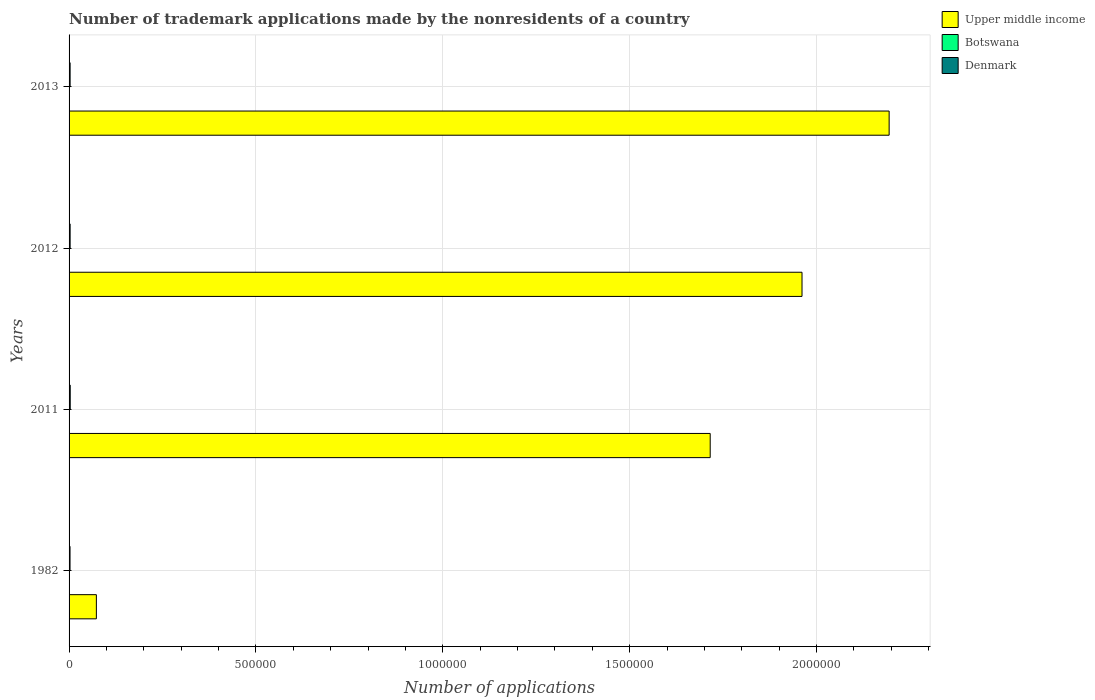How many different coloured bars are there?
Provide a short and direct response. 3. How many groups of bars are there?
Provide a short and direct response. 4. Are the number of bars per tick equal to the number of legend labels?
Your answer should be compact. Yes. How many bars are there on the 1st tick from the top?
Make the answer very short. 3. What is the number of trademark applications made by the nonresidents in Upper middle income in 1982?
Your response must be concise. 7.31e+04. Across all years, what is the maximum number of trademark applications made by the nonresidents in Botswana?
Your answer should be compact. 411. Across all years, what is the minimum number of trademark applications made by the nonresidents in Denmark?
Provide a short and direct response. 2556. In which year was the number of trademark applications made by the nonresidents in Botswana maximum?
Offer a very short reply. 2012. What is the total number of trademark applications made by the nonresidents in Upper middle income in the graph?
Ensure brevity in your answer.  5.94e+06. What is the difference between the number of trademark applications made by the nonresidents in Botswana in 2012 and that in 2013?
Provide a succinct answer. 53. What is the difference between the number of trademark applications made by the nonresidents in Denmark in 2013 and the number of trademark applications made by the nonresidents in Botswana in 1982?
Your answer should be very brief. 2789. What is the average number of trademark applications made by the nonresidents in Botswana per year?
Offer a very short reply. 275.5. In the year 1982, what is the difference between the number of trademark applications made by the nonresidents in Denmark and number of trademark applications made by the nonresidents in Upper middle income?
Offer a terse response. -7.05e+04. What is the ratio of the number of trademark applications made by the nonresidents in Upper middle income in 2011 to that in 2012?
Offer a terse response. 0.87. Is the number of trademark applications made by the nonresidents in Upper middle income in 2011 less than that in 2013?
Offer a terse response. Yes. Is the difference between the number of trademark applications made by the nonresidents in Denmark in 1982 and 2012 greater than the difference between the number of trademark applications made by the nonresidents in Upper middle income in 1982 and 2012?
Make the answer very short. Yes. What is the difference between the highest and the second highest number of trademark applications made by the nonresidents in Botswana?
Provide a succinct answer. 53. What is the difference between the highest and the lowest number of trademark applications made by the nonresidents in Upper middle income?
Ensure brevity in your answer.  2.12e+06. Is the sum of the number of trademark applications made by the nonresidents in Upper middle income in 2011 and 2012 greater than the maximum number of trademark applications made by the nonresidents in Botswana across all years?
Ensure brevity in your answer.  Yes. What does the 3rd bar from the top in 2013 represents?
Ensure brevity in your answer.  Upper middle income. What does the 2nd bar from the bottom in 2012 represents?
Make the answer very short. Botswana. How many bars are there?
Ensure brevity in your answer.  12. Are all the bars in the graph horizontal?
Your answer should be very brief. Yes. Are the values on the major ticks of X-axis written in scientific E-notation?
Ensure brevity in your answer.  No. Does the graph contain any zero values?
Keep it short and to the point. No. How many legend labels are there?
Keep it short and to the point. 3. What is the title of the graph?
Provide a short and direct response. Number of trademark applications made by the nonresidents of a country. What is the label or title of the X-axis?
Ensure brevity in your answer.  Number of applications. What is the label or title of the Y-axis?
Provide a short and direct response. Years. What is the Number of applications of Upper middle income in 1982?
Keep it short and to the point. 7.31e+04. What is the Number of applications in Botswana in 1982?
Provide a succinct answer. 4. What is the Number of applications of Denmark in 1982?
Ensure brevity in your answer.  2556. What is the Number of applications in Upper middle income in 2011?
Keep it short and to the point. 1.72e+06. What is the Number of applications in Botswana in 2011?
Give a very brief answer. 329. What is the Number of applications in Denmark in 2011?
Keep it short and to the point. 3060. What is the Number of applications in Upper middle income in 2012?
Keep it short and to the point. 1.96e+06. What is the Number of applications in Botswana in 2012?
Your answer should be very brief. 411. What is the Number of applications in Denmark in 2012?
Your answer should be compact. 2803. What is the Number of applications of Upper middle income in 2013?
Your answer should be compact. 2.19e+06. What is the Number of applications of Botswana in 2013?
Your answer should be very brief. 358. What is the Number of applications in Denmark in 2013?
Give a very brief answer. 2793. Across all years, what is the maximum Number of applications of Upper middle income?
Keep it short and to the point. 2.19e+06. Across all years, what is the maximum Number of applications in Botswana?
Your answer should be compact. 411. Across all years, what is the maximum Number of applications in Denmark?
Make the answer very short. 3060. Across all years, what is the minimum Number of applications in Upper middle income?
Provide a succinct answer. 7.31e+04. Across all years, what is the minimum Number of applications in Botswana?
Keep it short and to the point. 4. Across all years, what is the minimum Number of applications of Denmark?
Provide a short and direct response. 2556. What is the total Number of applications of Upper middle income in the graph?
Make the answer very short. 5.94e+06. What is the total Number of applications of Botswana in the graph?
Your answer should be compact. 1102. What is the total Number of applications in Denmark in the graph?
Give a very brief answer. 1.12e+04. What is the difference between the Number of applications in Upper middle income in 1982 and that in 2011?
Provide a short and direct response. -1.64e+06. What is the difference between the Number of applications of Botswana in 1982 and that in 2011?
Ensure brevity in your answer.  -325. What is the difference between the Number of applications of Denmark in 1982 and that in 2011?
Ensure brevity in your answer.  -504. What is the difference between the Number of applications of Upper middle income in 1982 and that in 2012?
Your response must be concise. -1.89e+06. What is the difference between the Number of applications of Botswana in 1982 and that in 2012?
Your response must be concise. -407. What is the difference between the Number of applications in Denmark in 1982 and that in 2012?
Make the answer very short. -247. What is the difference between the Number of applications of Upper middle income in 1982 and that in 2013?
Offer a very short reply. -2.12e+06. What is the difference between the Number of applications of Botswana in 1982 and that in 2013?
Offer a very short reply. -354. What is the difference between the Number of applications of Denmark in 1982 and that in 2013?
Provide a short and direct response. -237. What is the difference between the Number of applications of Upper middle income in 2011 and that in 2012?
Give a very brief answer. -2.46e+05. What is the difference between the Number of applications of Botswana in 2011 and that in 2012?
Make the answer very short. -82. What is the difference between the Number of applications of Denmark in 2011 and that in 2012?
Give a very brief answer. 257. What is the difference between the Number of applications of Upper middle income in 2011 and that in 2013?
Give a very brief answer. -4.79e+05. What is the difference between the Number of applications of Denmark in 2011 and that in 2013?
Your response must be concise. 267. What is the difference between the Number of applications of Upper middle income in 2012 and that in 2013?
Make the answer very short. -2.33e+05. What is the difference between the Number of applications in Denmark in 2012 and that in 2013?
Your answer should be very brief. 10. What is the difference between the Number of applications in Upper middle income in 1982 and the Number of applications in Botswana in 2011?
Keep it short and to the point. 7.27e+04. What is the difference between the Number of applications of Upper middle income in 1982 and the Number of applications of Denmark in 2011?
Make the answer very short. 7.00e+04. What is the difference between the Number of applications of Botswana in 1982 and the Number of applications of Denmark in 2011?
Your response must be concise. -3056. What is the difference between the Number of applications of Upper middle income in 1982 and the Number of applications of Botswana in 2012?
Make the answer very short. 7.27e+04. What is the difference between the Number of applications in Upper middle income in 1982 and the Number of applications in Denmark in 2012?
Give a very brief answer. 7.03e+04. What is the difference between the Number of applications of Botswana in 1982 and the Number of applications of Denmark in 2012?
Provide a short and direct response. -2799. What is the difference between the Number of applications in Upper middle income in 1982 and the Number of applications in Botswana in 2013?
Keep it short and to the point. 7.27e+04. What is the difference between the Number of applications in Upper middle income in 1982 and the Number of applications in Denmark in 2013?
Your response must be concise. 7.03e+04. What is the difference between the Number of applications of Botswana in 1982 and the Number of applications of Denmark in 2013?
Provide a short and direct response. -2789. What is the difference between the Number of applications in Upper middle income in 2011 and the Number of applications in Botswana in 2012?
Ensure brevity in your answer.  1.72e+06. What is the difference between the Number of applications in Upper middle income in 2011 and the Number of applications in Denmark in 2012?
Your response must be concise. 1.71e+06. What is the difference between the Number of applications of Botswana in 2011 and the Number of applications of Denmark in 2012?
Provide a succinct answer. -2474. What is the difference between the Number of applications in Upper middle income in 2011 and the Number of applications in Botswana in 2013?
Your answer should be very brief. 1.72e+06. What is the difference between the Number of applications in Upper middle income in 2011 and the Number of applications in Denmark in 2013?
Provide a succinct answer. 1.71e+06. What is the difference between the Number of applications in Botswana in 2011 and the Number of applications in Denmark in 2013?
Give a very brief answer. -2464. What is the difference between the Number of applications of Upper middle income in 2012 and the Number of applications of Botswana in 2013?
Keep it short and to the point. 1.96e+06. What is the difference between the Number of applications in Upper middle income in 2012 and the Number of applications in Denmark in 2013?
Your answer should be very brief. 1.96e+06. What is the difference between the Number of applications in Botswana in 2012 and the Number of applications in Denmark in 2013?
Offer a very short reply. -2382. What is the average Number of applications in Upper middle income per year?
Ensure brevity in your answer.  1.49e+06. What is the average Number of applications in Botswana per year?
Give a very brief answer. 275.5. What is the average Number of applications of Denmark per year?
Your answer should be compact. 2803. In the year 1982, what is the difference between the Number of applications in Upper middle income and Number of applications in Botswana?
Give a very brief answer. 7.31e+04. In the year 1982, what is the difference between the Number of applications in Upper middle income and Number of applications in Denmark?
Your response must be concise. 7.05e+04. In the year 1982, what is the difference between the Number of applications of Botswana and Number of applications of Denmark?
Your answer should be very brief. -2552. In the year 2011, what is the difference between the Number of applications in Upper middle income and Number of applications in Botswana?
Offer a very short reply. 1.72e+06. In the year 2011, what is the difference between the Number of applications in Upper middle income and Number of applications in Denmark?
Offer a terse response. 1.71e+06. In the year 2011, what is the difference between the Number of applications in Botswana and Number of applications in Denmark?
Your answer should be compact. -2731. In the year 2012, what is the difference between the Number of applications of Upper middle income and Number of applications of Botswana?
Your answer should be compact. 1.96e+06. In the year 2012, what is the difference between the Number of applications of Upper middle income and Number of applications of Denmark?
Ensure brevity in your answer.  1.96e+06. In the year 2012, what is the difference between the Number of applications of Botswana and Number of applications of Denmark?
Provide a succinct answer. -2392. In the year 2013, what is the difference between the Number of applications of Upper middle income and Number of applications of Botswana?
Give a very brief answer. 2.19e+06. In the year 2013, what is the difference between the Number of applications in Upper middle income and Number of applications in Denmark?
Provide a succinct answer. 2.19e+06. In the year 2013, what is the difference between the Number of applications in Botswana and Number of applications in Denmark?
Provide a succinct answer. -2435. What is the ratio of the Number of applications of Upper middle income in 1982 to that in 2011?
Your answer should be compact. 0.04. What is the ratio of the Number of applications in Botswana in 1982 to that in 2011?
Give a very brief answer. 0.01. What is the ratio of the Number of applications of Denmark in 1982 to that in 2011?
Provide a short and direct response. 0.84. What is the ratio of the Number of applications of Upper middle income in 1982 to that in 2012?
Offer a very short reply. 0.04. What is the ratio of the Number of applications in Botswana in 1982 to that in 2012?
Give a very brief answer. 0.01. What is the ratio of the Number of applications in Denmark in 1982 to that in 2012?
Ensure brevity in your answer.  0.91. What is the ratio of the Number of applications of Upper middle income in 1982 to that in 2013?
Offer a very short reply. 0.03. What is the ratio of the Number of applications in Botswana in 1982 to that in 2013?
Offer a very short reply. 0.01. What is the ratio of the Number of applications of Denmark in 1982 to that in 2013?
Make the answer very short. 0.92. What is the ratio of the Number of applications of Upper middle income in 2011 to that in 2012?
Your response must be concise. 0.87. What is the ratio of the Number of applications of Botswana in 2011 to that in 2012?
Ensure brevity in your answer.  0.8. What is the ratio of the Number of applications of Denmark in 2011 to that in 2012?
Your answer should be compact. 1.09. What is the ratio of the Number of applications of Upper middle income in 2011 to that in 2013?
Offer a very short reply. 0.78. What is the ratio of the Number of applications in Botswana in 2011 to that in 2013?
Offer a very short reply. 0.92. What is the ratio of the Number of applications in Denmark in 2011 to that in 2013?
Provide a short and direct response. 1.1. What is the ratio of the Number of applications of Upper middle income in 2012 to that in 2013?
Give a very brief answer. 0.89. What is the ratio of the Number of applications in Botswana in 2012 to that in 2013?
Keep it short and to the point. 1.15. What is the ratio of the Number of applications in Denmark in 2012 to that in 2013?
Offer a terse response. 1. What is the difference between the highest and the second highest Number of applications in Upper middle income?
Offer a terse response. 2.33e+05. What is the difference between the highest and the second highest Number of applications of Botswana?
Provide a succinct answer. 53. What is the difference between the highest and the second highest Number of applications of Denmark?
Your answer should be compact. 257. What is the difference between the highest and the lowest Number of applications of Upper middle income?
Your response must be concise. 2.12e+06. What is the difference between the highest and the lowest Number of applications in Botswana?
Your response must be concise. 407. What is the difference between the highest and the lowest Number of applications of Denmark?
Offer a very short reply. 504. 